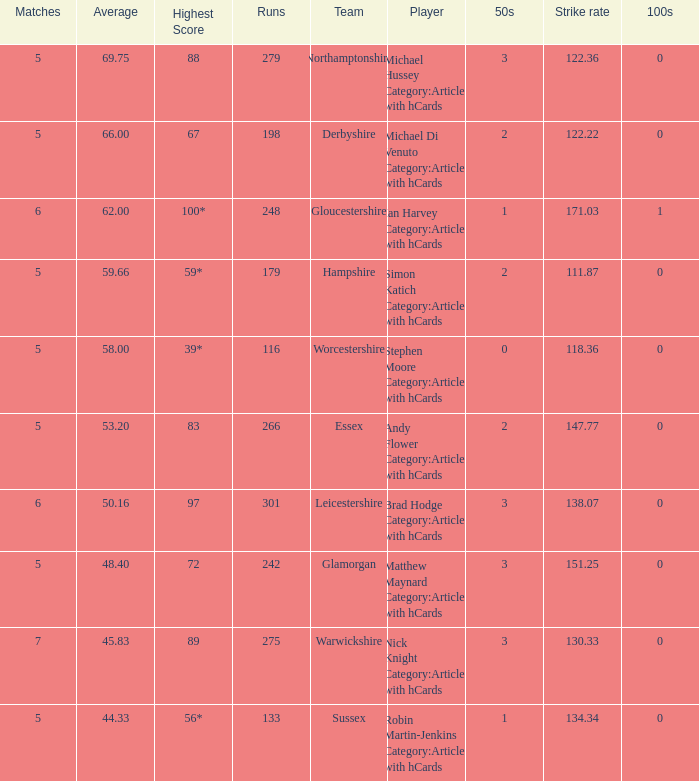If the team is Gloucestershire, what is the average? 62.0. 